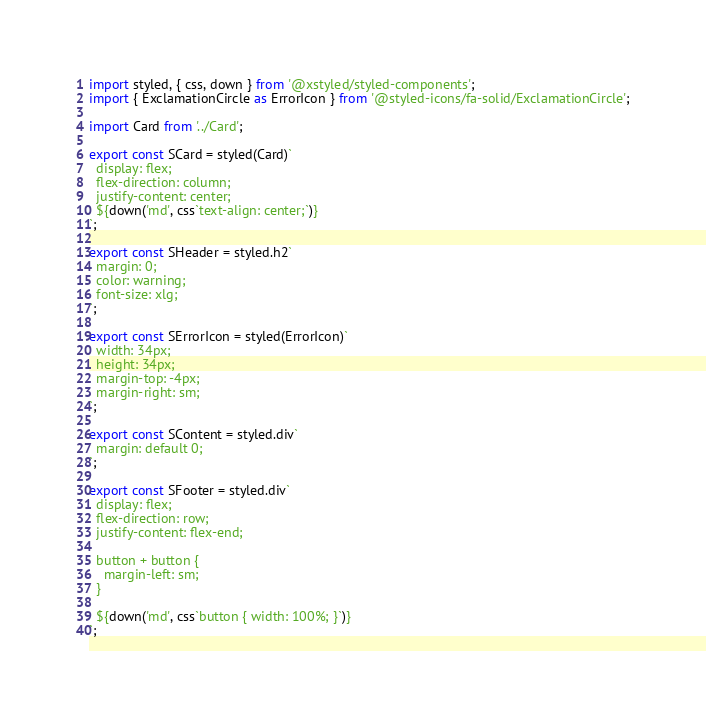Convert code to text. <code><loc_0><loc_0><loc_500><loc_500><_JavaScript_>import styled, { css, down } from '@xstyled/styled-components';
import { ExclamationCircle as ErrorIcon } from '@styled-icons/fa-solid/ExclamationCircle';

import Card from '../Card';

export const SCard = styled(Card)`
  display: flex;
  flex-direction: column;
  justify-content: center;
  ${down('md', css`text-align: center;`)}
`;

export const SHeader = styled.h2`
  margin: 0;
  color: warning;
  font-size: xlg;
`;

export const SErrorIcon = styled(ErrorIcon)`
  width: 34px;
  height: 34px;
  margin-top: -4px;
  margin-right: sm;
`;

export const SContent = styled.div`
  margin: default 0;
`;

export const SFooter = styled.div`
  display: flex;
  flex-direction: row;
  justify-content: flex-end;

  button + button {
    margin-left: sm;
  }

  ${down('md', css`button { width: 100%; }`)}
`;
</code> 